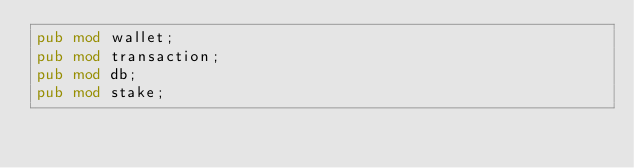<code> <loc_0><loc_0><loc_500><loc_500><_Rust_>pub mod wallet;
pub mod transaction;
pub mod db;
pub mod stake;</code> 